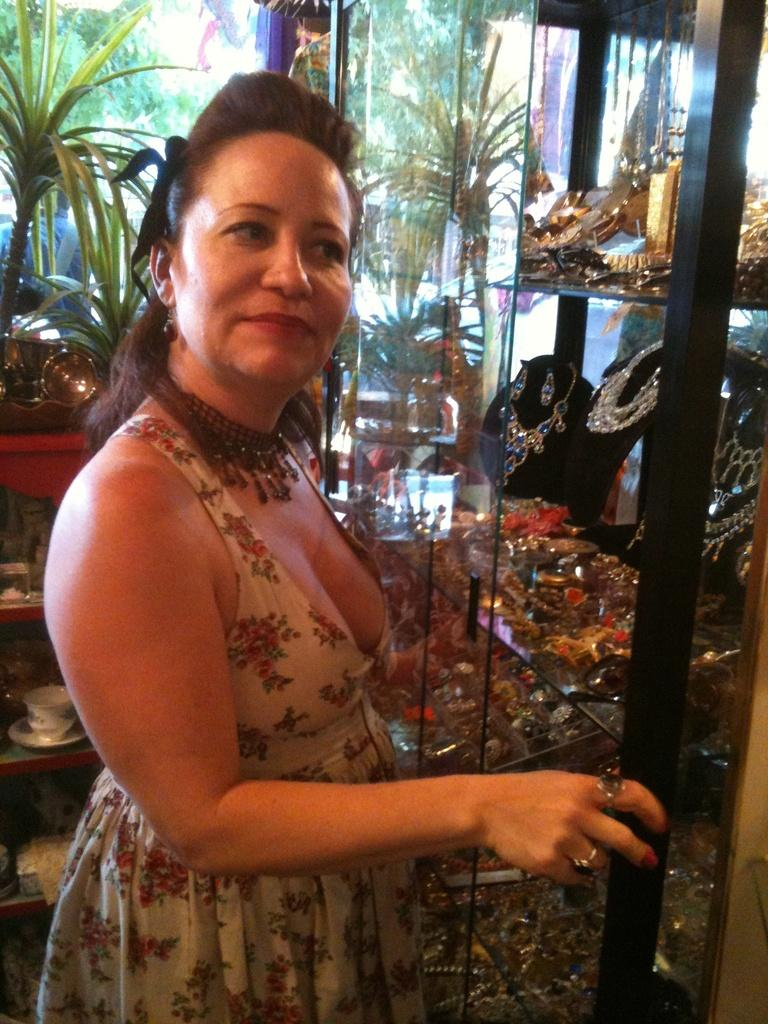Who is the main subject in the image? There is a lady in the image. What accessories is the lady wearing? The lady is wearing a necklace and a cap. What else can be seen in the image besides the lady? There are other objects in the image. Can you describe the background of the image? There is a person and trees in the background of the image. What type of coil is being used by the lady in the image? There is no coil present in the image. Can you tell me how many bananas are on the table in the image? There is no table or bananas present in the image. Is the lady playing a game of chess with the person in the background? There is no chessboard or game being played in the image. 